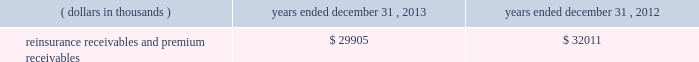In addition , the company has reclassified the following amounts from 201cdistributions from other invested assets 201d included in cash flows from investing activities to 201cdistribution of limited partnership income 201d included in cash flows from operations for interim reporting periods of 2013 : $ 33686 thousand for the three months ended march 31 , 2013 ; $ 9409 thousand and $ 43095 thousand for the three months and six months ended june 30 , 2013 , respectively ; and $ 5638 thousand and $ 48733 thousand for the three months and nine months ended september 30 , 2013 , respectively .
Investments .
Fixed maturity and equity security investments available for sale , at market value , reflect unrealized appreciation and depreciation , as a result of temporary changes in market value during the period , in shareholders 2019 equity , net of income taxes in 201caccumulated other comprehensive income ( loss ) 201d in the consolidated balance sheets .
Fixed maturity and equity securities carried at fair value reflect fair value re- measurements as net realized capital gains and losses in the consolidated statements of operations and comprehensive income ( loss ) .
The company records changes in fair value for its fixed maturities available for sale , at market value through shareholders 2019 equity , net of taxes in accumulated other comprehensive income ( loss ) since cash flows from these investments will be primarily used to settle its reserve for losses and loss adjustment expense liabilities .
The company anticipates holding these investments for an extended period as the cash flow from interest and maturities will fund the projected payout of these liabilities .
Fixed maturities carried at fair value represent a portfolio of convertible bond securities , which have characteristics similar to equity securities and at times , designated foreign denominated fixed maturity securities , which will be used to settle loss and loss adjustment reserves in the same currency .
The company carries all of its equity securities at fair value except for mutual fund investments whose underlying investments are comprised of fixed maturity securities .
For equity securities , available for sale , at fair value , the company reflects changes in value as net realized capital gains and losses since these securities may be sold in the near term depending on financial market conditions .
Interest income on all fixed maturities and dividend income on all equity securities are included as part of net investment income in the consolidated statements of operations and comprehensive income ( loss ) .
Unrealized losses on fixed maturities , which are deemed other-than-temporary and related to the credit quality of a security , are charged to net income ( loss ) as net realized capital losses .
Short-term investments are stated at cost , which approximates market value .
Realized gains or losses on sales of investments are determined on the basis of identified cost .
For non- publicly traded securities , market prices are determined through the use of pricing models that evaluate securities relative to the u.s .
Treasury yield curve , taking into account the issue type , credit quality , and cash flow characteristics of each security .
For publicly traded securities , market value is based on quoted market prices or valuation models that use observable market inputs .
When a sector of the financial markets is inactive or illiquid , the company may use its own assumptions about future cash flows and risk-adjusted discount rates to determine fair value .
Retrospective adjustments are employed to recalculate the values of asset-backed securities .
Each acquisition lot is reviewed to recalculate the effective yield .
The recalculated effective yield is used to derive a book value as if the new yield were applied at the time of acquisition .
Outstanding principal factors from the time of acquisition to the adjustment date are used to calculate the prepayment history for all applicable securities .
Conditional prepayment rates , computed with life to date factor histories and weighted average maturities , are used to effect the calculation of projected and prepayments for pass-through security types .
Other invested assets include limited partnerships , rabbi trusts and an affiliated entity .
Limited partnerships and the affiliated entity are accounted for under the equity method of accounting , which can be recorded on a monthly or quarterly lag .
Uncollectible receivable balances .
The company provides reserves for uncollectible reinsurance recoverable and premium receivable balances based on management 2019s assessment of the collectability of the outstanding balances .
Such reserves are presented in the table below for the periods indicated. .

What is the net change in the balance of reinsurance receivables and premium receivables in 2013? 
Computations: (29905 - 32011)
Answer: -2106.0. 